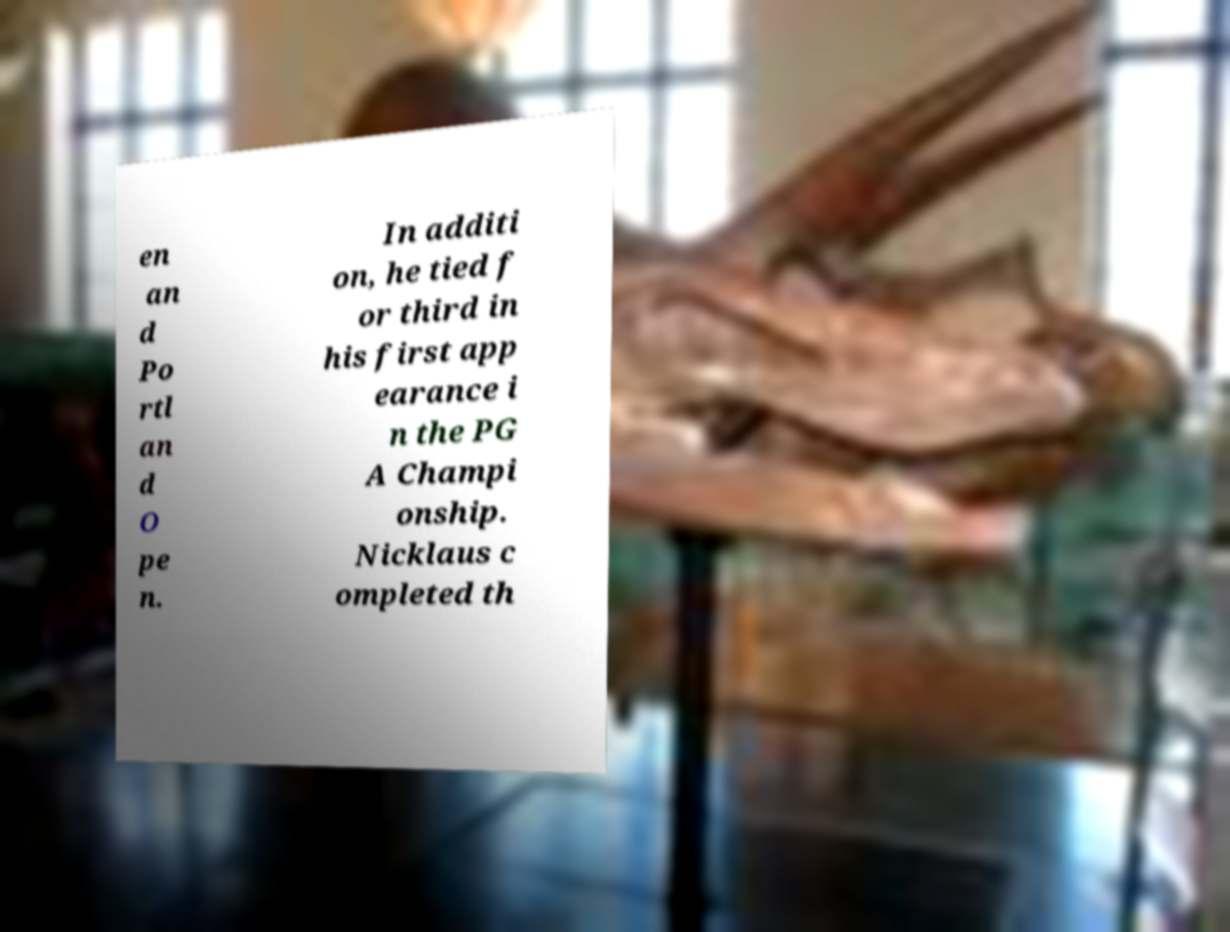There's text embedded in this image that I need extracted. Can you transcribe it verbatim? en an d Po rtl an d O pe n. In additi on, he tied f or third in his first app earance i n the PG A Champi onship. Nicklaus c ompleted th 